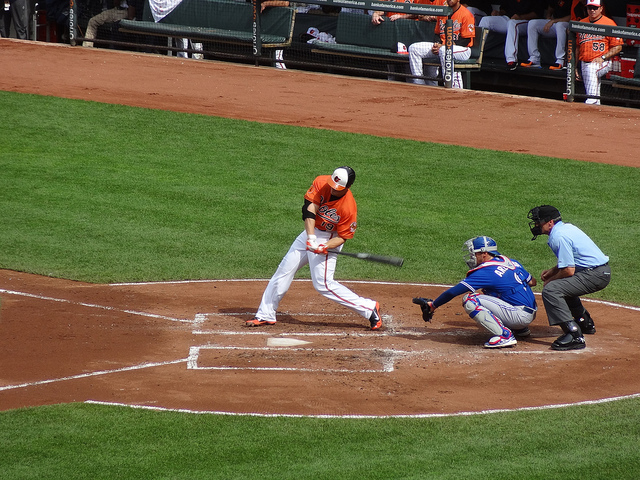Please identify all text content in this image. Onoles 